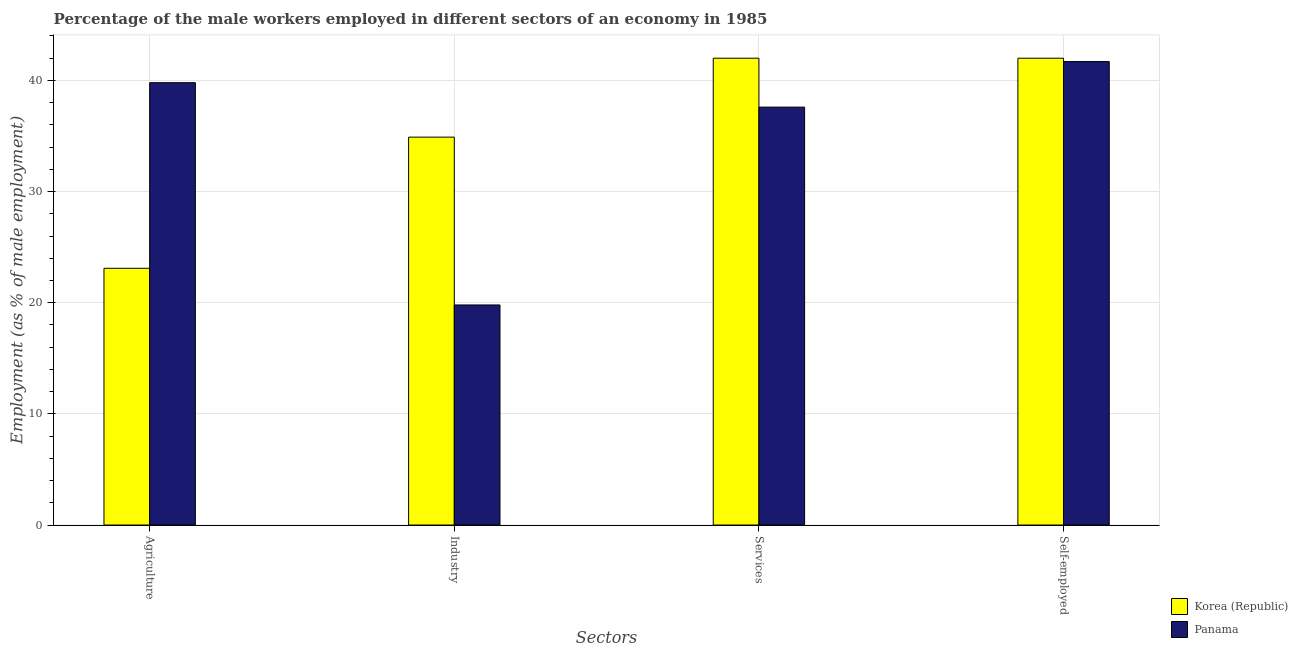How many different coloured bars are there?
Make the answer very short. 2. How many groups of bars are there?
Make the answer very short. 4. How many bars are there on the 2nd tick from the left?
Ensure brevity in your answer.  2. What is the label of the 3rd group of bars from the left?
Keep it short and to the point. Services. What is the percentage of male workers in industry in Korea (Republic)?
Keep it short and to the point. 34.9. Across all countries, what is the minimum percentage of self employed male workers?
Your answer should be very brief. 41.7. In which country was the percentage of self employed male workers maximum?
Make the answer very short. Korea (Republic). In which country was the percentage of male workers in industry minimum?
Offer a terse response. Panama. What is the total percentage of self employed male workers in the graph?
Keep it short and to the point. 83.7. What is the difference between the percentage of self employed male workers in Panama and that in Korea (Republic)?
Offer a terse response. -0.3. What is the difference between the percentage of male workers in industry in Korea (Republic) and the percentage of self employed male workers in Panama?
Make the answer very short. -6.8. What is the average percentage of male workers in industry per country?
Offer a very short reply. 27.35. What is the difference between the percentage of male workers in services and percentage of male workers in agriculture in Panama?
Offer a very short reply. -2.2. What is the ratio of the percentage of self employed male workers in Korea (Republic) to that in Panama?
Your answer should be compact. 1.01. Is the difference between the percentage of male workers in industry in Korea (Republic) and Panama greater than the difference between the percentage of self employed male workers in Korea (Republic) and Panama?
Give a very brief answer. Yes. What is the difference between the highest and the second highest percentage of male workers in services?
Provide a succinct answer. 4.4. What is the difference between the highest and the lowest percentage of male workers in industry?
Provide a short and direct response. 15.1. In how many countries, is the percentage of male workers in services greater than the average percentage of male workers in services taken over all countries?
Provide a succinct answer. 1. Is it the case that in every country, the sum of the percentage of male workers in services and percentage of male workers in agriculture is greater than the sum of percentage of self employed male workers and percentage of male workers in industry?
Ensure brevity in your answer.  No. What does the 2nd bar from the left in Self-employed represents?
Your response must be concise. Panama. What does the 2nd bar from the right in Industry represents?
Provide a short and direct response. Korea (Republic). Is it the case that in every country, the sum of the percentage of male workers in agriculture and percentage of male workers in industry is greater than the percentage of male workers in services?
Ensure brevity in your answer.  Yes. Are all the bars in the graph horizontal?
Your response must be concise. No. How many countries are there in the graph?
Provide a short and direct response. 2. Are the values on the major ticks of Y-axis written in scientific E-notation?
Provide a short and direct response. No. Does the graph contain any zero values?
Make the answer very short. No. What is the title of the graph?
Offer a very short reply. Percentage of the male workers employed in different sectors of an economy in 1985. What is the label or title of the X-axis?
Make the answer very short. Sectors. What is the label or title of the Y-axis?
Make the answer very short. Employment (as % of male employment). What is the Employment (as % of male employment) of Korea (Republic) in Agriculture?
Give a very brief answer. 23.1. What is the Employment (as % of male employment) in Panama in Agriculture?
Keep it short and to the point. 39.8. What is the Employment (as % of male employment) of Korea (Republic) in Industry?
Make the answer very short. 34.9. What is the Employment (as % of male employment) of Panama in Industry?
Make the answer very short. 19.8. What is the Employment (as % of male employment) in Korea (Republic) in Services?
Give a very brief answer. 42. What is the Employment (as % of male employment) of Panama in Services?
Offer a very short reply. 37.6. What is the Employment (as % of male employment) in Panama in Self-employed?
Offer a terse response. 41.7. Across all Sectors, what is the maximum Employment (as % of male employment) of Korea (Republic)?
Make the answer very short. 42. Across all Sectors, what is the maximum Employment (as % of male employment) of Panama?
Offer a very short reply. 41.7. Across all Sectors, what is the minimum Employment (as % of male employment) of Korea (Republic)?
Your answer should be compact. 23.1. Across all Sectors, what is the minimum Employment (as % of male employment) of Panama?
Ensure brevity in your answer.  19.8. What is the total Employment (as % of male employment) in Korea (Republic) in the graph?
Provide a succinct answer. 142. What is the total Employment (as % of male employment) in Panama in the graph?
Make the answer very short. 138.9. What is the difference between the Employment (as % of male employment) of Korea (Republic) in Agriculture and that in Services?
Your response must be concise. -18.9. What is the difference between the Employment (as % of male employment) in Korea (Republic) in Agriculture and that in Self-employed?
Your answer should be compact. -18.9. What is the difference between the Employment (as % of male employment) in Korea (Republic) in Industry and that in Services?
Your answer should be compact. -7.1. What is the difference between the Employment (as % of male employment) of Panama in Industry and that in Services?
Ensure brevity in your answer.  -17.8. What is the difference between the Employment (as % of male employment) of Panama in Industry and that in Self-employed?
Your answer should be compact. -21.9. What is the difference between the Employment (as % of male employment) of Korea (Republic) in Services and that in Self-employed?
Offer a very short reply. 0. What is the difference between the Employment (as % of male employment) in Korea (Republic) in Agriculture and the Employment (as % of male employment) in Panama in Industry?
Provide a short and direct response. 3.3. What is the difference between the Employment (as % of male employment) in Korea (Republic) in Agriculture and the Employment (as % of male employment) in Panama in Services?
Your answer should be very brief. -14.5. What is the difference between the Employment (as % of male employment) of Korea (Republic) in Agriculture and the Employment (as % of male employment) of Panama in Self-employed?
Keep it short and to the point. -18.6. What is the difference between the Employment (as % of male employment) of Korea (Republic) in Industry and the Employment (as % of male employment) of Panama in Self-employed?
Keep it short and to the point. -6.8. What is the difference between the Employment (as % of male employment) in Korea (Republic) in Services and the Employment (as % of male employment) in Panama in Self-employed?
Make the answer very short. 0.3. What is the average Employment (as % of male employment) of Korea (Republic) per Sectors?
Provide a short and direct response. 35.5. What is the average Employment (as % of male employment) of Panama per Sectors?
Offer a very short reply. 34.73. What is the difference between the Employment (as % of male employment) in Korea (Republic) and Employment (as % of male employment) in Panama in Agriculture?
Your response must be concise. -16.7. What is the difference between the Employment (as % of male employment) of Korea (Republic) and Employment (as % of male employment) of Panama in Services?
Make the answer very short. 4.4. What is the ratio of the Employment (as % of male employment) in Korea (Republic) in Agriculture to that in Industry?
Offer a very short reply. 0.66. What is the ratio of the Employment (as % of male employment) of Panama in Agriculture to that in Industry?
Your answer should be very brief. 2.01. What is the ratio of the Employment (as % of male employment) in Korea (Republic) in Agriculture to that in Services?
Your answer should be compact. 0.55. What is the ratio of the Employment (as % of male employment) in Panama in Agriculture to that in Services?
Provide a succinct answer. 1.06. What is the ratio of the Employment (as % of male employment) of Korea (Republic) in Agriculture to that in Self-employed?
Ensure brevity in your answer.  0.55. What is the ratio of the Employment (as % of male employment) of Panama in Agriculture to that in Self-employed?
Your answer should be compact. 0.95. What is the ratio of the Employment (as % of male employment) of Korea (Republic) in Industry to that in Services?
Provide a short and direct response. 0.83. What is the ratio of the Employment (as % of male employment) of Panama in Industry to that in Services?
Offer a terse response. 0.53. What is the ratio of the Employment (as % of male employment) in Korea (Republic) in Industry to that in Self-employed?
Offer a terse response. 0.83. What is the ratio of the Employment (as % of male employment) of Panama in Industry to that in Self-employed?
Your response must be concise. 0.47. What is the ratio of the Employment (as % of male employment) of Panama in Services to that in Self-employed?
Your response must be concise. 0.9. What is the difference between the highest and the second highest Employment (as % of male employment) in Korea (Republic)?
Give a very brief answer. 0. What is the difference between the highest and the lowest Employment (as % of male employment) in Panama?
Your answer should be very brief. 21.9. 